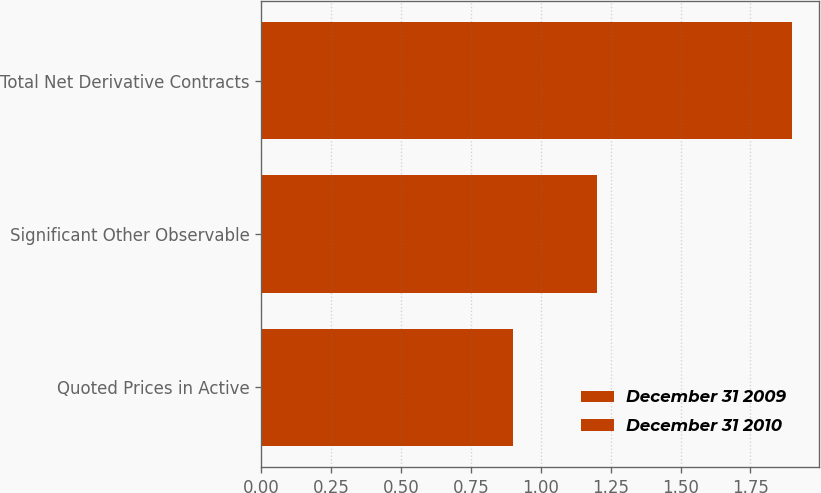Convert chart to OTSL. <chart><loc_0><loc_0><loc_500><loc_500><stacked_bar_chart><ecel><fcel>Quoted Prices in Active<fcel>Significant Other Observable<fcel>Total Net Derivative Contracts<nl><fcel>December 31 2009<fcel>0.8<fcel>0.6<fcel>1.4<nl><fcel>December 31 2010<fcel>0.1<fcel>0.6<fcel>0.5<nl></chart> 